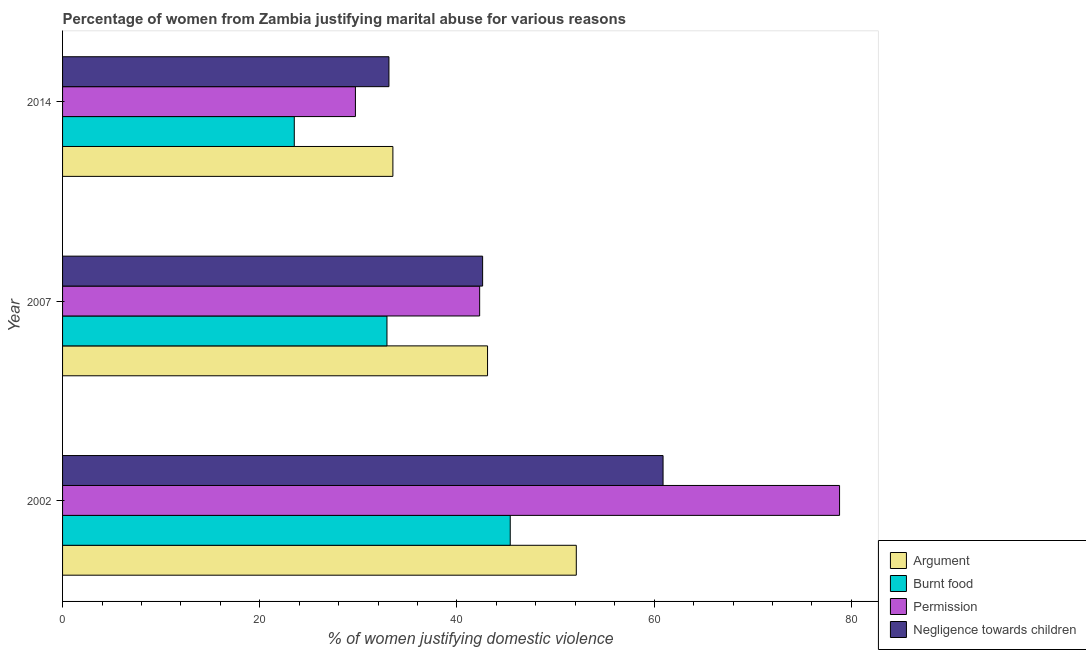How many different coloured bars are there?
Give a very brief answer. 4. Are the number of bars per tick equal to the number of legend labels?
Provide a succinct answer. Yes. What is the label of the 3rd group of bars from the top?
Offer a very short reply. 2002. What is the percentage of women justifying abuse for showing negligence towards children in 2007?
Offer a terse response. 42.6. Across all years, what is the maximum percentage of women justifying abuse for showing negligence towards children?
Ensure brevity in your answer.  60.9. Across all years, what is the minimum percentage of women justifying abuse in the case of an argument?
Provide a short and direct response. 33.5. What is the total percentage of women justifying abuse for showing negligence towards children in the graph?
Keep it short and to the point. 136.6. What is the difference between the percentage of women justifying abuse for going without permission in 2014 and the percentage of women justifying abuse for burning food in 2007?
Make the answer very short. -3.2. What is the average percentage of women justifying abuse for burning food per year?
Offer a very short reply. 33.93. In how many years, is the percentage of women justifying abuse for showing negligence towards children greater than 28 %?
Keep it short and to the point. 3. What is the ratio of the percentage of women justifying abuse for burning food in 2002 to that in 2014?
Your answer should be compact. 1.93. What is the difference between the highest and the second highest percentage of women justifying abuse in the case of an argument?
Your answer should be very brief. 9. What is the difference between the highest and the lowest percentage of women justifying abuse for burning food?
Provide a short and direct response. 21.9. Is the sum of the percentage of women justifying abuse for showing negligence towards children in 2002 and 2007 greater than the maximum percentage of women justifying abuse for going without permission across all years?
Your response must be concise. Yes. Is it the case that in every year, the sum of the percentage of women justifying abuse for burning food and percentage of women justifying abuse for going without permission is greater than the sum of percentage of women justifying abuse for showing negligence towards children and percentage of women justifying abuse in the case of an argument?
Your answer should be very brief. No. What does the 1st bar from the top in 2014 represents?
Keep it short and to the point. Negligence towards children. What does the 4th bar from the bottom in 2002 represents?
Keep it short and to the point. Negligence towards children. Is it the case that in every year, the sum of the percentage of women justifying abuse in the case of an argument and percentage of women justifying abuse for burning food is greater than the percentage of women justifying abuse for going without permission?
Provide a short and direct response. Yes. How many bars are there?
Provide a succinct answer. 12. Are all the bars in the graph horizontal?
Ensure brevity in your answer.  Yes. Are the values on the major ticks of X-axis written in scientific E-notation?
Your answer should be compact. No. Where does the legend appear in the graph?
Give a very brief answer. Bottom right. How many legend labels are there?
Ensure brevity in your answer.  4. How are the legend labels stacked?
Keep it short and to the point. Vertical. What is the title of the graph?
Offer a very short reply. Percentage of women from Zambia justifying marital abuse for various reasons. What is the label or title of the X-axis?
Make the answer very short. % of women justifying domestic violence. What is the label or title of the Y-axis?
Your answer should be compact. Year. What is the % of women justifying domestic violence of Argument in 2002?
Offer a very short reply. 52.1. What is the % of women justifying domestic violence in Burnt food in 2002?
Make the answer very short. 45.4. What is the % of women justifying domestic violence of Permission in 2002?
Your answer should be very brief. 78.8. What is the % of women justifying domestic violence of Negligence towards children in 2002?
Ensure brevity in your answer.  60.9. What is the % of women justifying domestic violence in Argument in 2007?
Keep it short and to the point. 43.1. What is the % of women justifying domestic violence of Burnt food in 2007?
Offer a very short reply. 32.9. What is the % of women justifying domestic violence of Permission in 2007?
Give a very brief answer. 42.3. What is the % of women justifying domestic violence of Negligence towards children in 2007?
Your answer should be very brief. 42.6. What is the % of women justifying domestic violence in Argument in 2014?
Your response must be concise. 33.5. What is the % of women justifying domestic violence in Permission in 2014?
Ensure brevity in your answer.  29.7. What is the % of women justifying domestic violence of Negligence towards children in 2014?
Keep it short and to the point. 33.1. Across all years, what is the maximum % of women justifying domestic violence of Argument?
Keep it short and to the point. 52.1. Across all years, what is the maximum % of women justifying domestic violence in Burnt food?
Provide a short and direct response. 45.4. Across all years, what is the maximum % of women justifying domestic violence of Permission?
Provide a succinct answer. 78.8. Across all years, what is the maximum % of women justifying domestic violence of Negligence towards children?
Your response must be concise. 60.9. Across all years, what is the minimum % of women justifying domestic violence of Argument?
Keep it short and to the point. 33.5. Across all years, what is the minimum % of women justifying domestic violence of Permission?
Offer a terse response. 29.7. Across all years, what is the minimum % of women justifying domestic violence of Negligence towards children?
Offer a very short reply. 33.1. What is the total % of women justifying domestic violence of Argument in the graph?
Give a very brief answer. 128.7. What is the total % of women justifying domestic violence of Burnt food in the graph?
Keep it short and to the point. 101.8. What is the total % of women justifying domestic violence in Permission in the graph?
Your answer should be compact. 150.8. What is the total % of women justifying domestic violence of Negligence towards children in the graph?
Your response must be concise. 136.6. What is the difference between the % of women justifying domestic violence in Permission in 2002 and that in 2007?
Offer a terse response. 36.5. What is the difference between the % of women justifying domestic violence in Burnt food in 2002 and that in 2014?
Your answer should be very brief. 21.9. What is the difference between the % of women justifying domestic violence in Permission in 2002 and that in 2014?
Your answer should be compact. 49.1. What is the difference between the % of women justifying domestic violence in Negligence towards children in 2002 and that in 2014?
Give a very brief answer. 27.8. What is the difference between the % of women justifying domestic violence of Argument in 2007 and that in 2014?
Provide a short and direct response. 9.6. What is the difference between the % of women justifying domestic violence of Permission in 2007 and that in 2014?
Ensure brevity in your answer.  12.6. What is the difference between the % of women justifying domestic violence in Negligence towards children in 2007 and that in 2014?
Provide a short and direct response. 9.5. What is the difference between the % of women justifying domestic violence of Argument in 2002 and the % of women justifying domestic violence of Burnt food in 2007?
Ensure brevity in your answer.  19.2. What is the difference between the % of women justifying domestic violence of Argument in 2002 and the % of women justifying domestic violence of Permission in 2007?
Ensure brevity in your answer.  9.8. What is the difference between the % of women justifying domestic violence in Argument in 2002 and the % of women justifying domestic violence in Negligence towards children in 2007?
Your response must be concise. 9.5. What is the difference between the % of women justifying domestic violence of Burnt food in 2002 and the % of women justifying domestic violence of Negligence towards children in 2007?
Ensure brevity in your answer.  2.8. What is the difference between the % of women justifying domestic violence in Permission in 2002 and the % of women justifying domestic violence in Negligence towards children in 2007?
Your answer should be very brief. 36.2. What is the difference between the % of women justifying domestic violence of Argument in 2002 and the % of women justifying domestic violence of Burnt food in 2014?
Offer a very short reply. 28.6. What is the difference between the % of women justifying domestic violence of Argument in 2002 and the % of women justifying domestic violence of Permission in 2014?
Provide a succinct answer. 22.4. What is the difference between the % of women justifying domestic violence in Burnt food in 2002 and the % of women justifying domestic violence in Negligence towards children in 2014?
Your answer should be very brief. 12.3. What is the difference between the % of women justifying domestic violence of Permission in 2002 and the % of women justifying domestic violence of Negligence towards children in 2014?
Your response must be concise. 45.7. What is the difference between the % of women justifying domestic violence in Argument in 2007 and the % of women justifying domestic violence in Burnt food in 2014?
Give a very brief answer. 19.6. What is the difference between the % of women justifying domestic violence of Argument in 2007 and the % of women justifying domestic violence of Negligence towards children in 2014?
Offer a terse response. 10. What is the average % of women justifying domestic violence of Argument per year?
Give a very brief answer. 42.9. What is the average % of women justifying domestic violence of Burnt food per year?
Offer a very short reply. 33.93. What is the average % of women justifying domestic violence of Permission per year?
Offer a terse response. 50.27. What is the average % of women justifying domestic violence in Negligence towards children per year?
Provide a short and direct response. 45.53. In the year 2002, what is the difference between the % of women justifying domestic violence of Argument and % of women justifying domestic violence of Burnt food?
Provide a short and direct response. 6.7. In the year 2002, what is the difference between the % of women justifying domestic violence in Argument and % of women justifying domestic violence in Permission?
Make the answer very short. -26.7. In the year 2002, what is the difference between the % of women justifying domestic violence of Argument and % of women justifying domestic violence of Negligence towards children?
Your response must be concise. -8.8. In the year 2002, what is the difference between the % of women justifying domestic violence of Burnt food and % of women justifying domestic violence of Permission?
Make the answer very short. -33.4. In the year 2002, what is the difference between the % of women justifying domestic violence of Burnt food and % of women justifying domestic violence of Negligence towards children?
Offer a terse response. -15.5. In the year 2007, what is the difference between the % of women justifying domestic violence in Argument and % of women justifying domestic violence in Burnt food?
Offer a very short reply. 10.2. In the year 2007, what is the difference between the % of women justifying domestic violence in Argument and % of women justifying domestic violence in Negligence towards children?
Offer a terse response. 0.5. In the year 2007, what is the difference between the % of women justifying domestic violence of Burnt food and % of women justifying domestic violence of Permission?
Make the answer very short. -9.4. In the year 2007, what is the difference between the % of women justifying domestic violence of Burnt food and % of women justifying domestic violence of Negligence towards children?
Make the answer very short. -9.7. In the year 2014, what is the difference between the % of women justifying domestic violence in Argument and % of women justifying domestic violence in Burnt food?
Ensure brevity in your answer.  10. In the year 2014, what is the difference between the % of women justifying domestic violence in Argument and % of women justifying domestic violence in Permission?
Provide a short and direct response. 3.8. In the year 2014, what is the difference between the % of women justifying domestic violence of Argument and % of women justifying domestic violence of Negligence towards children?
Your answer should be very brief. 0.4. In the year 2014, what is the difference between the % of women justifying domestic violence of Burnt food and % of women justifying domestic violence of Negligence towards children?
Offer a very short reply. -9.6. In the year 2014, what is the difference between the % of women justifying domestic violence of Permission and % of women justifying domestic violence of Negligence towards children?
Offer a very short reply. -3.4. What is the ratio of the % of women justifying domestic violence of Argument in 2002 to that in 2007?
Offer a very short reply. 1.21. What is the ratio of the % of women justifying domestic violence of Burnt food in 2002 to that in 2007?
Provide a short and direct response. 1.38. What is the ratio of the % of women justifying domestic violence of Permission in 2002 to that in 2007?
Your answer should be compact. 1.86. What is the ratio of the % of women justifying domestic violence in Negligence towards children in 2002 to that in 2007?
Your answer should be compact. 1.43. What is the ratio of the % of women justifying domestic violence of Argument in 2002 to that in 2014?
Provide a short and direct response. 1.56. What is the ratio of the % of women justifying domestic violence in Burnt food in 2002 to that in 2014?
Provide a short and direct response. 1.93. What is the ratio of the % of women justifying domestic violence in Permission in 2002 to that in 2014?
Offer a terse response. 2.65. What is the ratio of the % of women justifying domestic violence of Negligence towards children in 2002 to that in 2014?
Your answer should be very brief. 1.84. What is the ratio of the % of women justifying domestic violence of Argument in 2007 to that in 2014?
Give a very brief answer. 1.29. What is the ratio of the % of women justifying domestic violence of Permission in 2007 to that in 2014?
Your answer should be very brief. 1.42. What is the ratio of the % of women justifying domestic violence of Negligence towards children in 2007 to that in 2014?
Ensure brevity in your answer.  1.29. What is the difference between the highest and the second highest % of women justifying domestic violence of Burnt food?
Offer a terse response. 12.5. What is the difference between the highest and the second highest % of women justifying domestic violence of Permission?
Offer a very short reply. 36.5. What is the difference between the highest and the second highest % of women justifying domestic violence of Negligence towards children?
Give a very brief answer. 18.3. What is the difference between the highest and the lowest % of women justifying domestic violence in Argument?
Keep it short and to the point. 18.6. What is the difference between the highest and the lowest % of women justifying domestic violence of Burnt food?
Make the answer very short. 21.9. What is the difference between the highest and the lowest % of women justifying domestic violence of Permission?
Offer a very short reply. 49.1. What is the difference between the highest and the lowest % of women justifying domestic violence of Negligence towards children?
Provide a short and direct response. 27.8. 